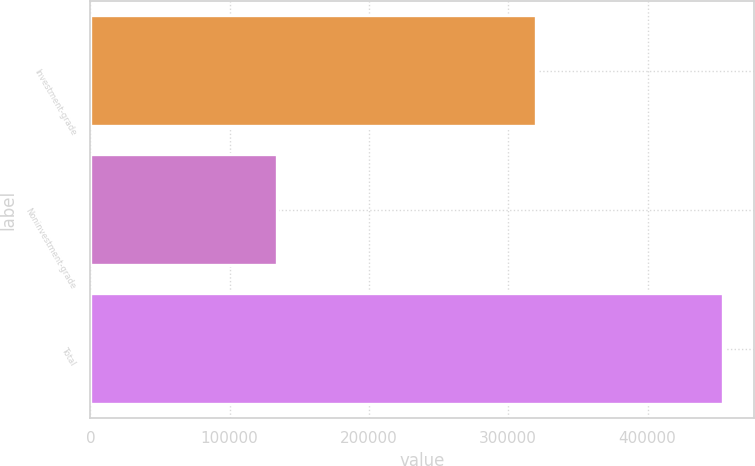<chart> <loc_0><loc_0><loc_500><loc_500><bar_chart><fcel>Investment-grade<fcel>Noninvestment-grade<fcel>Total<nl><fcel>319726<fcel>134125<fcel>453851<nl></chart> 